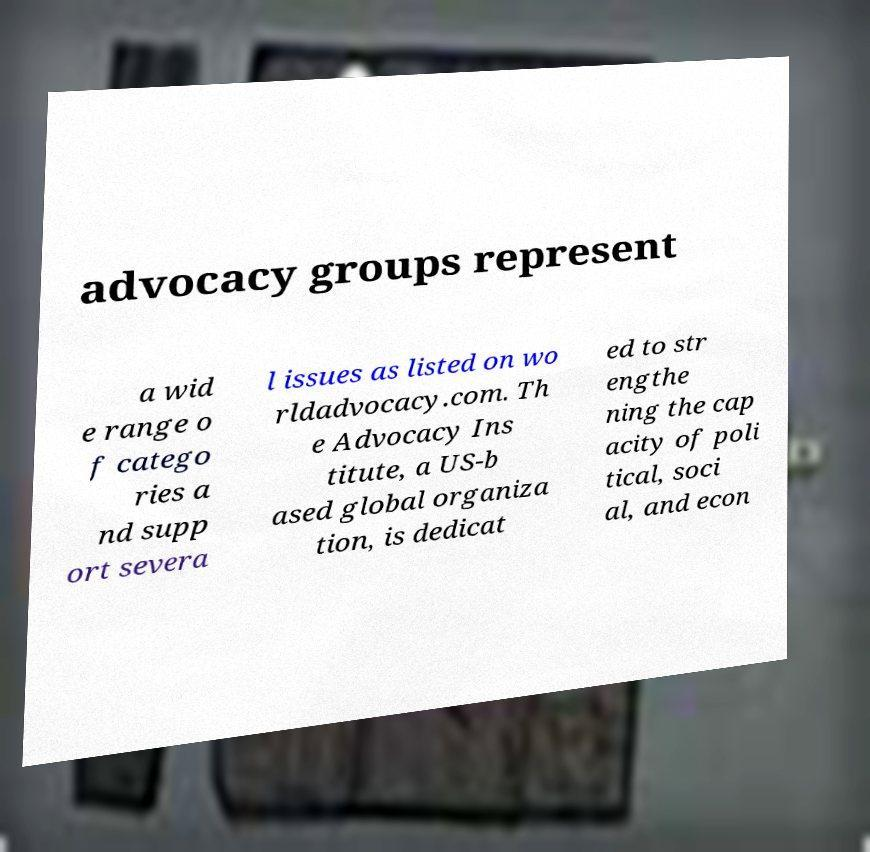Please read and relay the text visible in this image. What does it say? advocacy groups represent a wid e range o f catego ries a nd supp ort severa l issues as listed on wo rldadvocacy.com. Th e Advocacy Ins titute, a US-b ased global organiza tion, is dedicat ed to str engthe ning the cap acity of poli tical, soci al, and econ 